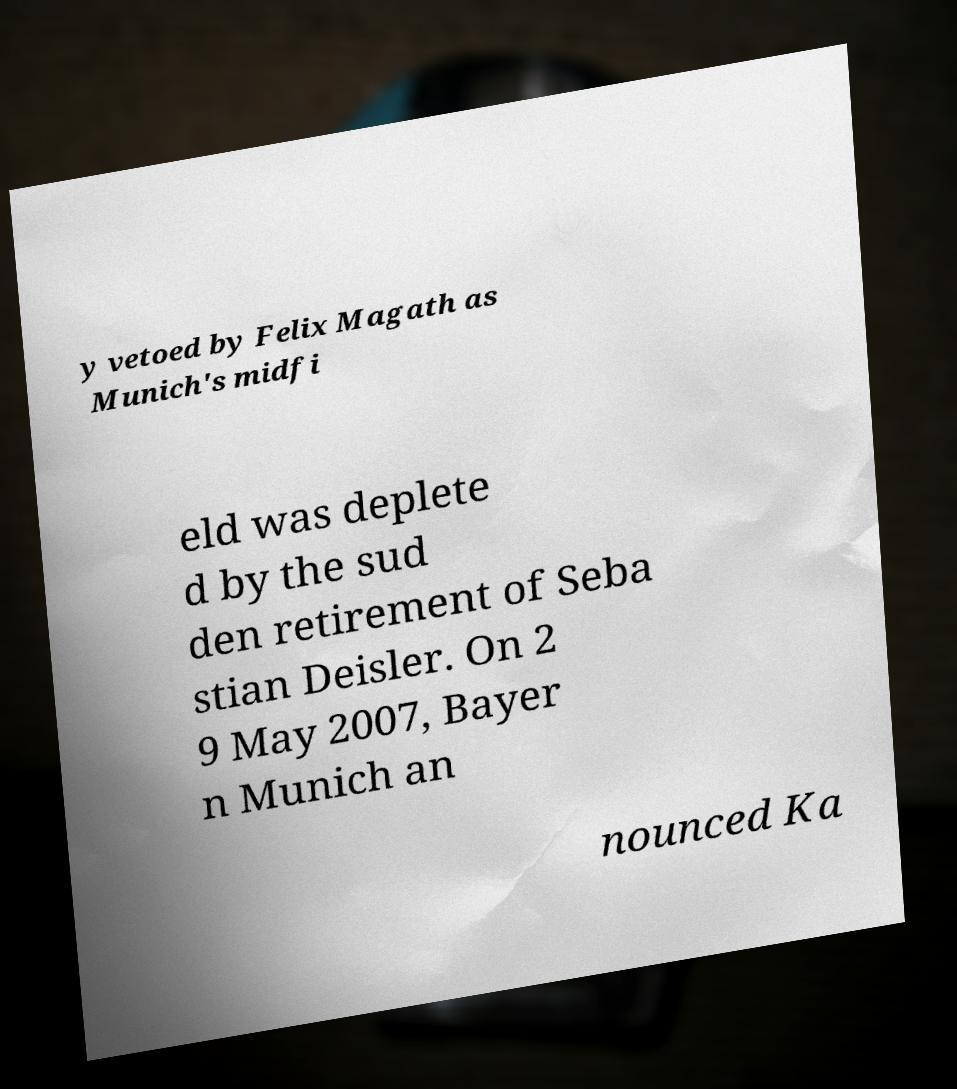There's text embedded in this image that I need extracted. Can you transcribe it verbatim? y vetoed by Felix Magath as Munich's midfi eld was deplete d by the sud den retirement of Seba stian Deisler. On 2 9 May 2007, Bayer n Munich an nounced Ka 